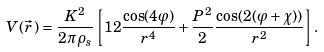Convert formula to latex. <formula><loc_0><loc_0><loc_500><loc_500>V ( \vec { r } \, ) = \frac { K ^ { 2 } } { 2 \pi \rho _ { s } } \left [ 1 2 \frac { \cos ( 4 \varphi ) } { r ^ { 4 } } + \frac { P ^ { 2 } } { 2 } \frac { \cos ( 2 ( \varphi + \chi ) ) } { r ^ { 2 } } \right ] .</formula> 